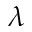<formula> <loc_0><loc_0><loc_500><loc_500>\lambda</formula> 